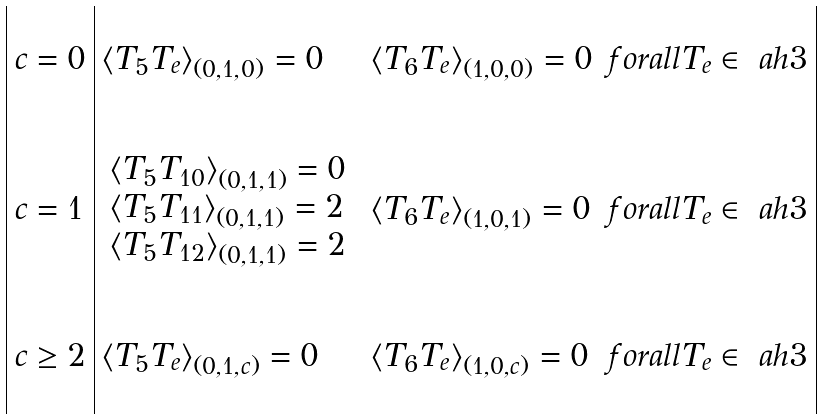<formula> <loc_0><loc_0><loc_500><loc_500>\begin{array} { | l | l l l | } & & & \\ c = 0 & \langle T _ { 5 } T _ { e } \rangle _ { ( 0 , 1 , 0 ) } = 0 & \langle T _ { 6 } T _ { e } \rangle _ { ( 1 , 0 , 0 ) } = 0 & f o r a l l T _ { e } \in \ a h { 3 } \\ & & & \\ & & & \\ c = 1 & \begin{array} { l } \langle T _ { 5 } T _ { 1 0 } \rangle _ { ( 0 , 1 , 1 ) } = 0 \\ \langle T _ { 5 } T _ { 1 1 } \rangle _ { ( 0 , 1 , 1 ) } = 2 \\ \langle T _ { 5 } T _ { 1 2 } \rangle _ { ( 0 , 1 , 1 ) } = 2 \\ \end{array} & \langle T _ { 6 } T _ { e } \rangle _ { ( 1 , 0 , 1 ) } = 0 & f o r a l l T _ { e } \in \ a h { 3 } \\ & & & \\ & & & \\ c \geq 2 & \langle T _ { 5 } T _ { e } \rangle _ { ( 0 , 1 , c ) } = 0 & \langle T _ { 6 } T _ { e } \rangle _ { ( 1 , 0 , c ) } = 0 & f o r a l l T _ { e } \in \ a h { 3 } \\ & & & \\ \end{array}</formula> 